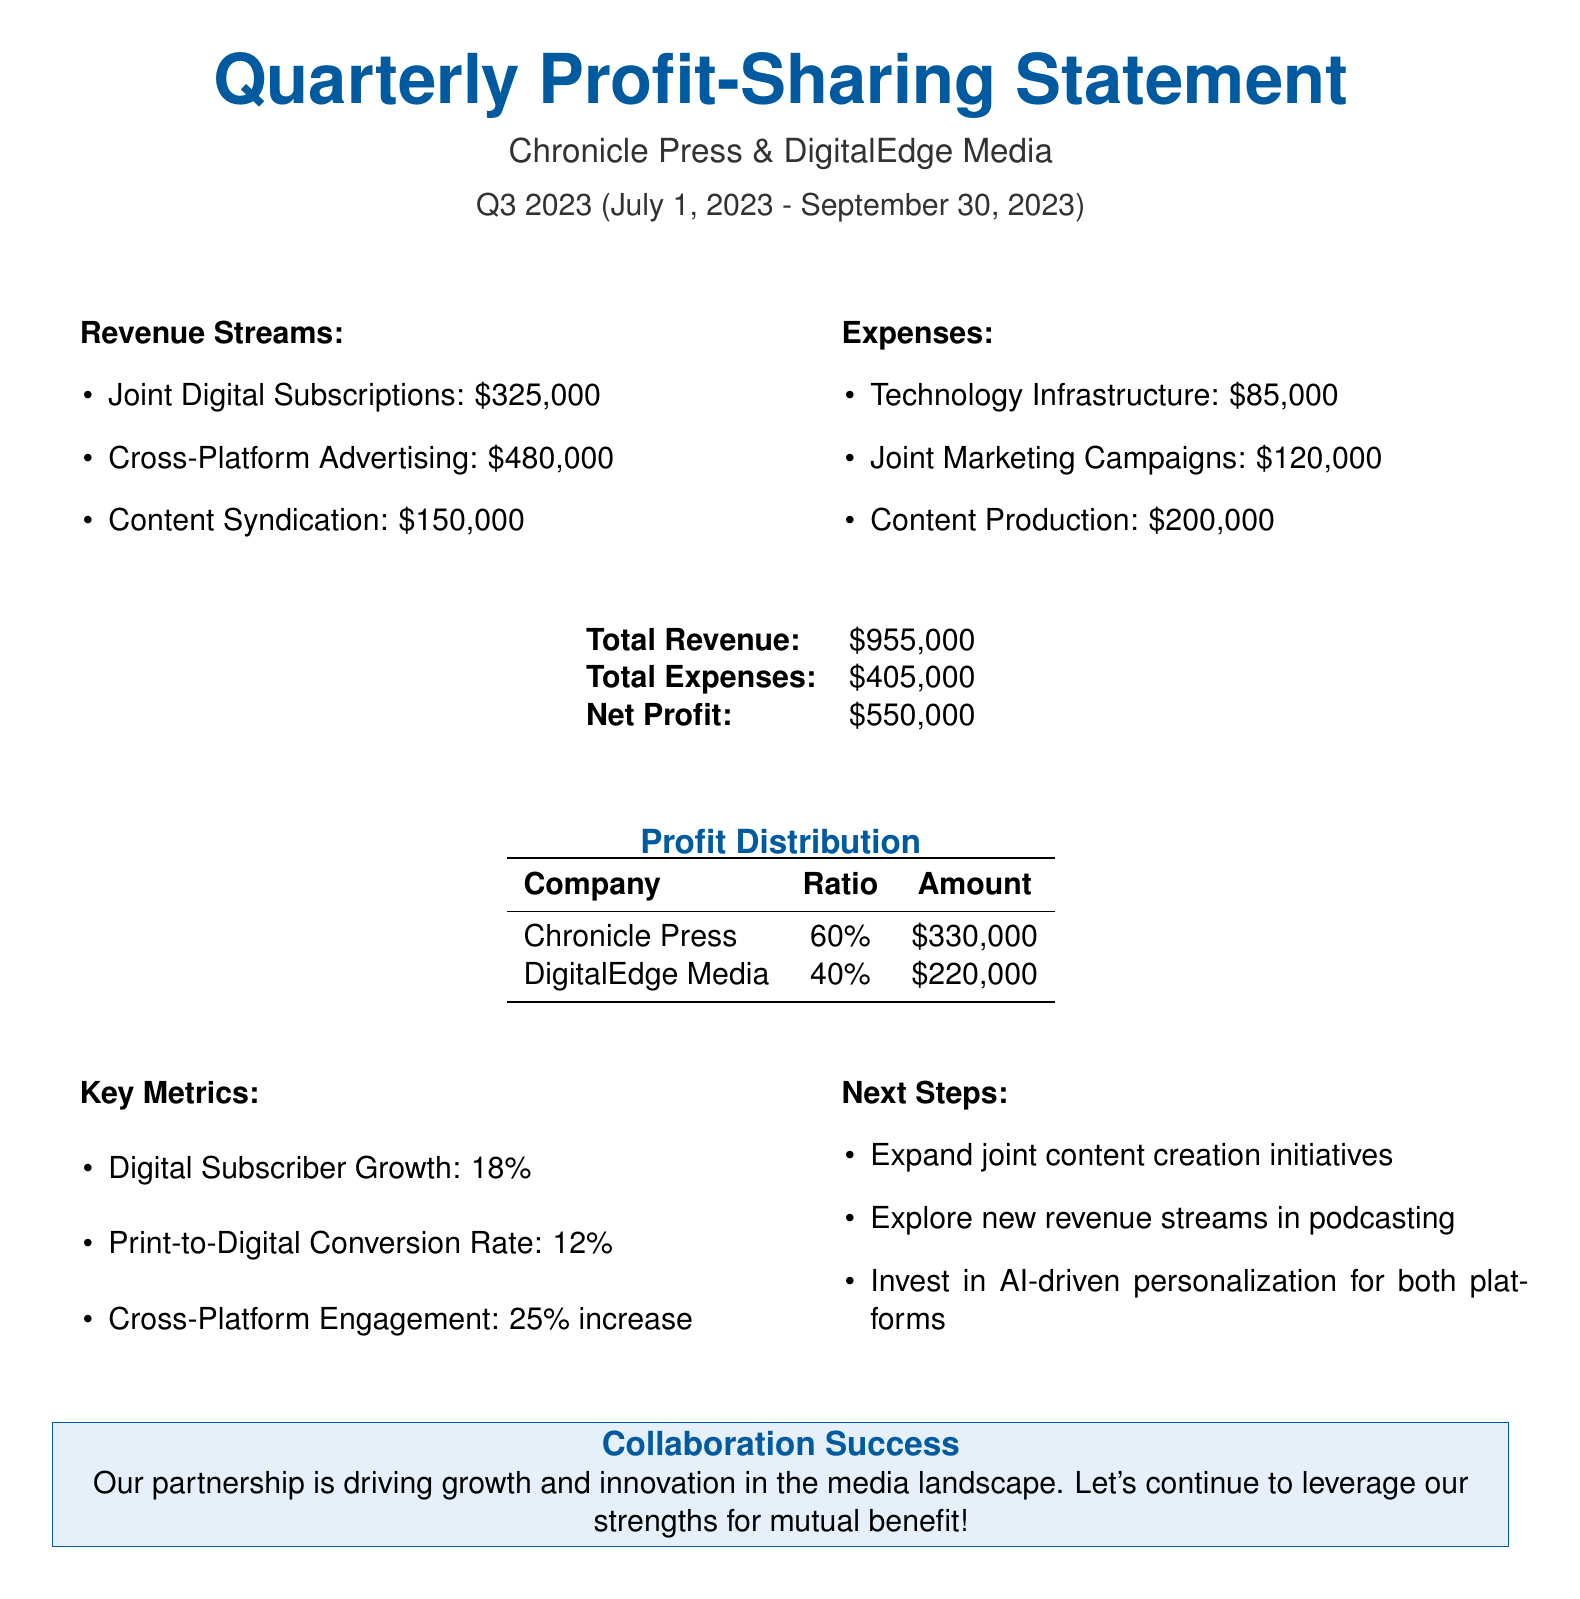what is the total revenue? The total revenue is the sum of all revenue sources listed in the document.
Answer: $955,000 what are the joint digital subscriptions revenue? The document lists the revenue from joint digital subscriptions, which is one of the revenue streams.
Answer: $325,000 what percentage of the net profit does Chronicle Press receive? The profit distribution table shows that Chronicle Press receives 60% of the net profit.
Answer: 60% what is the net profit for this quarter? The net profit is calculated as total revenue minus total expenses, as provided in the document.
Answer: $550,000 how much did DigitalEdge Media earn from the profit distribution? The profit distribution table indicates the amount DigitalEdge Media earned.
Answer: $220,000 what is the digital subscriber growth percentage? The key metrics section states the percentage of digital subscriber growth for the quarter.
Answer: 18% what is one next step mentioned in the document? The document lists next steps in the collaboration, highlighting actions to be taken.
Answer: Expand joint content creation initiatives what is the duration of this profit-sharing statement? The document specifies the start and end dates of the quarter represented in the statement.
Answer: July 1, 2023 - September 30, 2023 what was the total expenses for the quarter? The total expenses are provided in the summary section of the document.
Answer: $405,000 